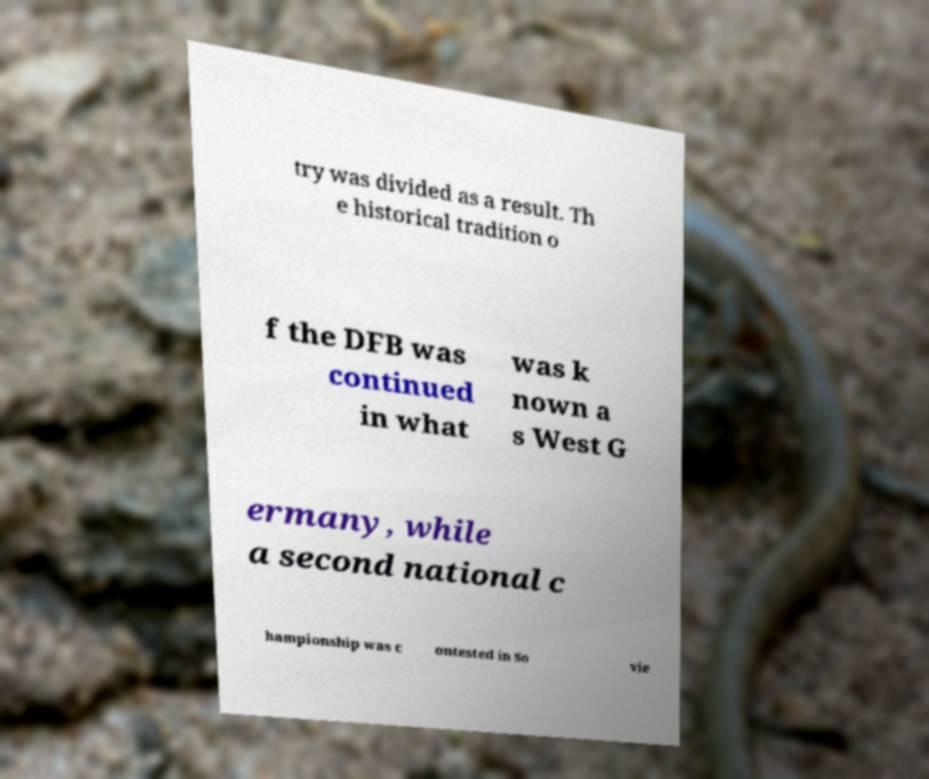Can you accurately transcribe the text from the provided image for me? try was divided as a result. Th e historical tradition o f the DFB was continued in what was k nown a s West G ermany, while a second national c hampionship was c ontested in So vie 